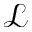Convert formula to latex. <formula><loc_0><loc_0><loc_500><loc_500>\mathcal { L }</formula> 